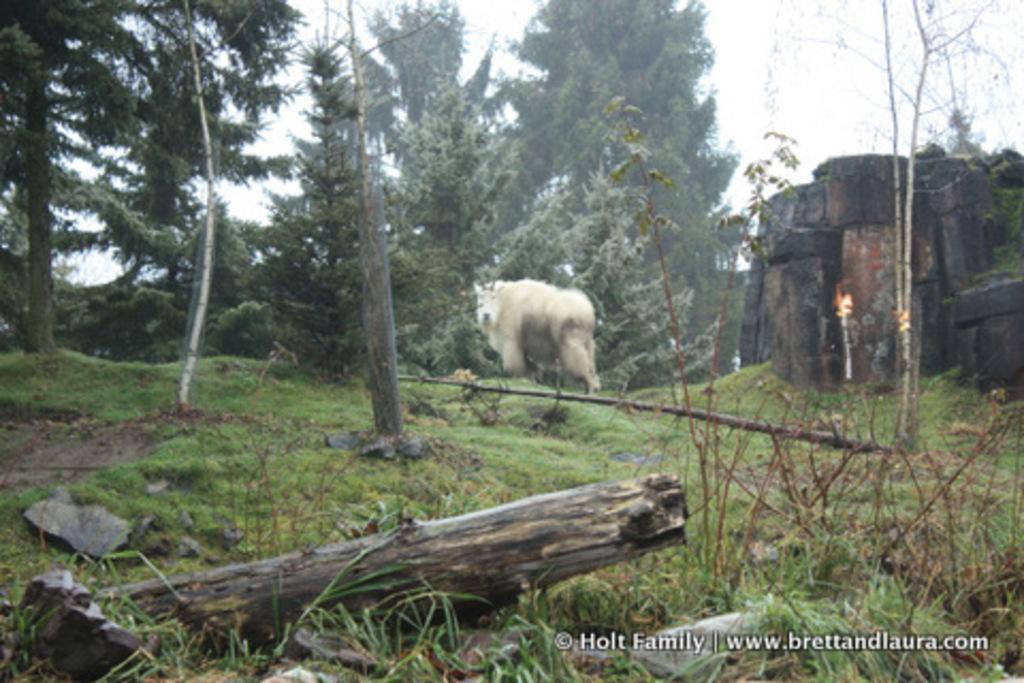Could you give a brief overview of what you see in this image? In this image at the bottom there is grass and some rocks, and there are some wooden sticks. In the center there is an animal, and on the right side of the image there is wall and some plants and in the background there are trees. At the top there is sky. 